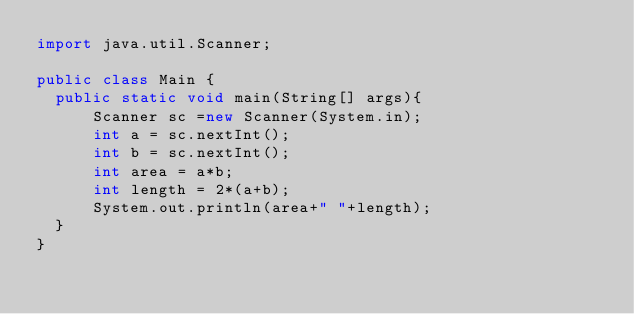<code> <loc_0><loc_0><loc_500><loc_500><_Java_>import java.util.Scanner;

public class Main {
  public static void main(String[] args){
	  Scanner sc =new Scanner(System.in);
	  int a = sc.nextInt();
	  int b = sc.nextInt();
	  int area = a*b;
      int length = 2*(a+b);
      System.out.println(area+" "+length);
  }
}</code> 